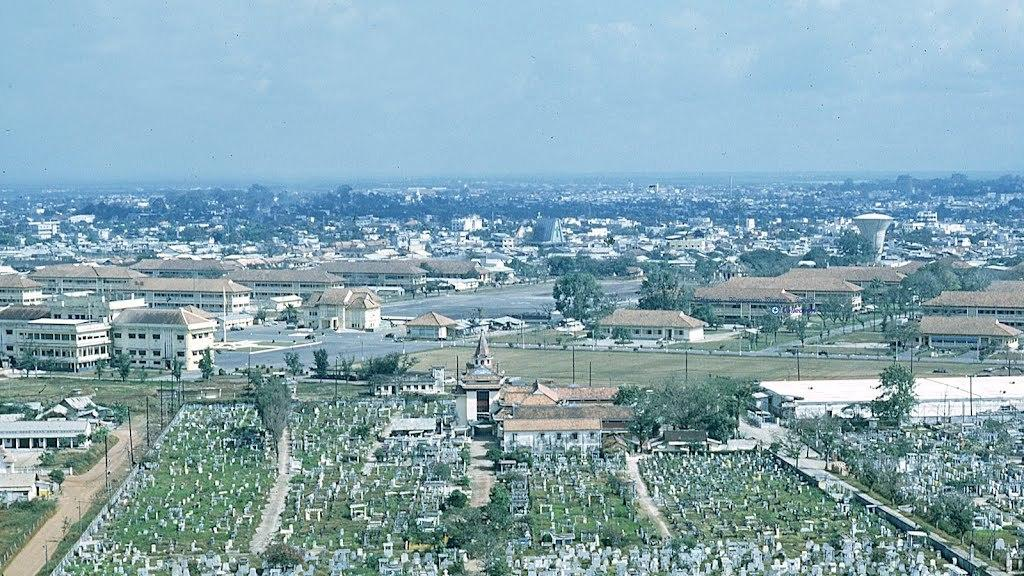What type of structures can be seen in the image? There are buildings in the image. What other natural elements are present in the image? There are trees in the image. Are there any man-made objects besides buildings? Yes, there are poles in the image. What is the color of the sky in the image? The sky is blue and white in color. Can you see any boats floating in the sky in the image? No, there are no boats visible in the image, and the sky is blue and white, not a body of water. What color is the crayon used to draw the trees in the image? There is no crayon present in the image; the trees are depicted using photographic or illustrative techniques. 